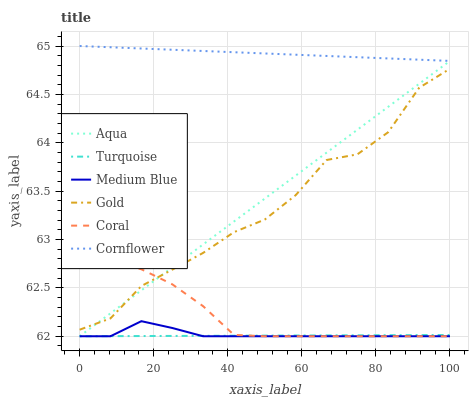Does Turquoise have the minimum area under the curve?
Answer yes or no. Yes. Does Cornflower have the maximum area under the curve?
Answer yes or no. Yes. Does Gold have the minimum area under the curve?
Answer yes or no. No. Does Gold have the maximum area under the curve?
Answer yes or no. No. Is Turquoise the smoothest?
Answer yes or no. Yes. Is Gold the roughest?
Answer yes or no. Yes. Is Gold the smoothest?
Answer yes or no. No. Is Turquoise the roughest?
Answer yes or no. No. Does Gold have the lowest value?
Answer yes or no. No. Does Gold have the highest value?
Answer yes or no. No. Is Coral less than Cornflower?
Answer yes or no. Yes. Is Cornflower greater than Coral?
Answer yes or no. Yes. Does Coral intersect Cornflower?
Answer yes or no. No. 